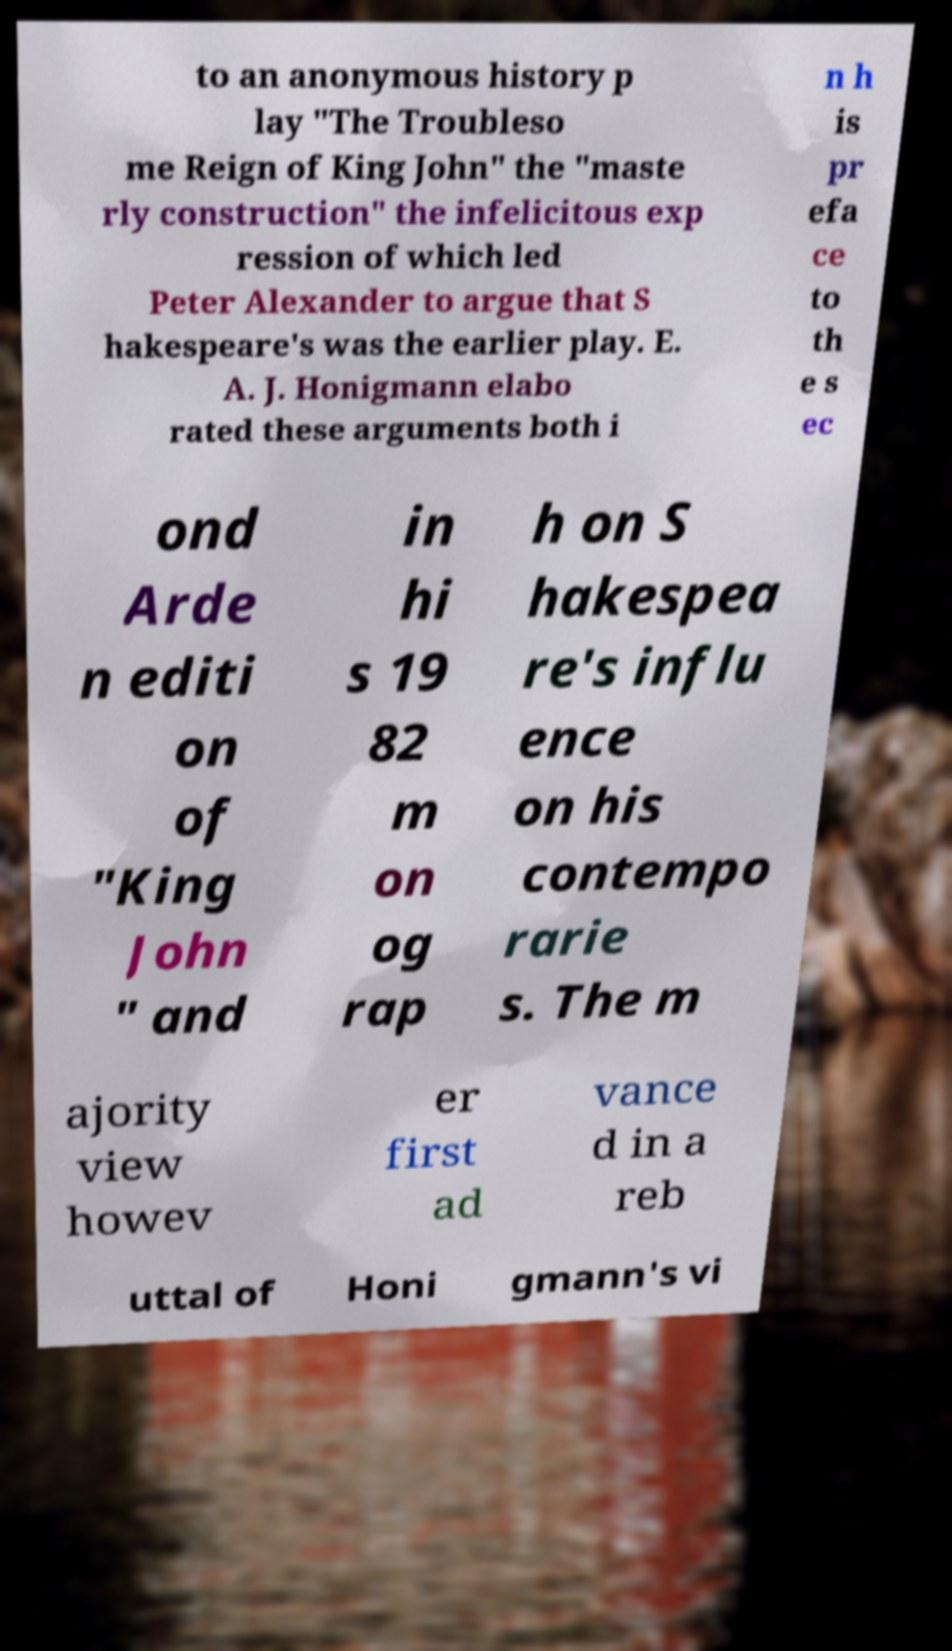Could you extract and type out the text from this image? to an anonymous history p lay "The Troubleso me Reign of King John" the "maste rly construction" the infelicitous exp ression of which led Peter Alexander to argue that S hakespeare's was the earlier play. E. A. J. Honigmann elabo rated these arguments both i n h is pr efa ce to th e s ec ond Arde n editi on of "King John " and in hi s 19 82 m on og rap h on S hakespea re's influ ence on his contempo rarie s. The m ajority view howev er first ad vance d in a reb uttal of Honi gmann's vi 